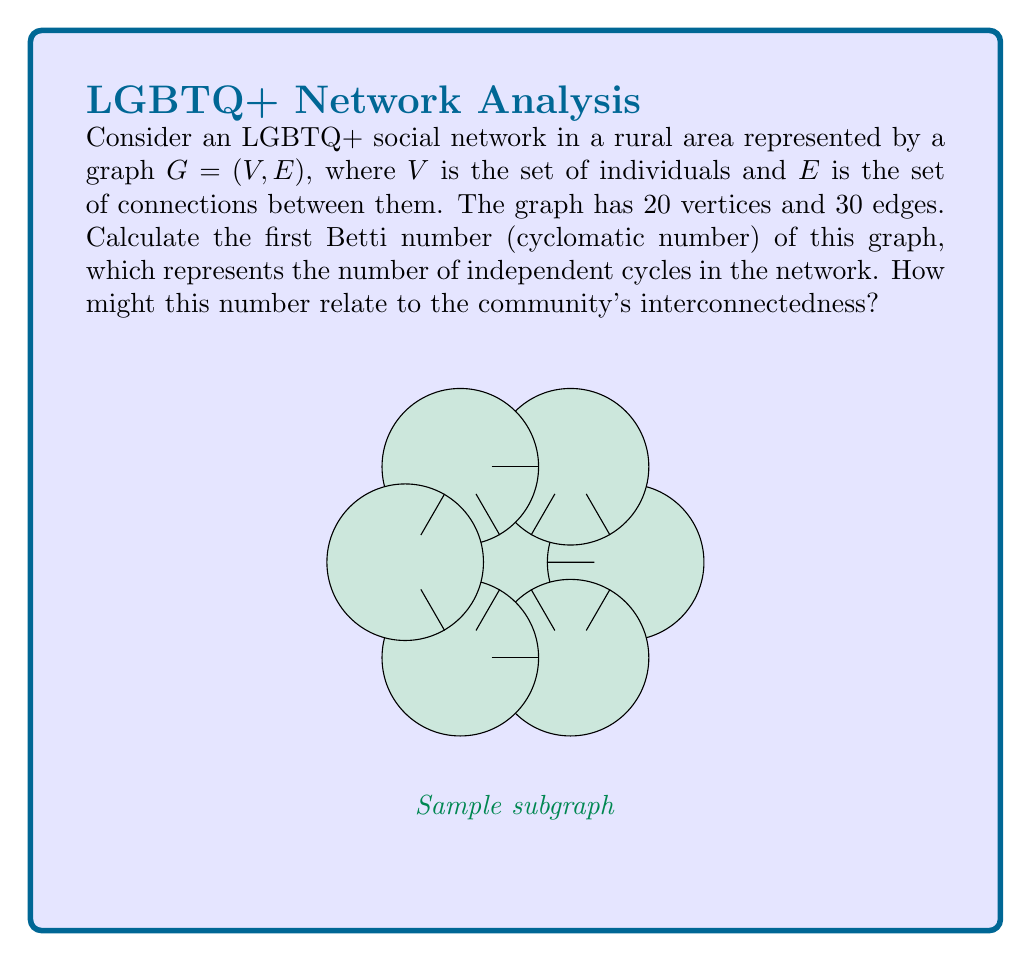Can you solve this math problem? To solve this problem, we'll follow these steps:

1) First, recall the formula for the first Betti number (cyclomatic number) of a graph:

   $$ \beta_1 = |E| - |V| + c $$

   where $|E|$ is the number of edges, $|V|$ is the number of vertices, and $c$ is the number of connected components.

2) We're given that:
   - $|V| = 20$ (number of vertices)
   - $|E| = 30$ (number of edges)

3) We need to determine $c$. Since this represents a social network in a rural area, it's reasonable to assume that all individuals are connected in some way, forming a single component. Therefore, $c = 1$.

4) Now we can substitute these values into our formula:

   $$ \beta_1 = 30 - 20 + 1 = 11 $$

5) Interpretation: The first Betti number of 11 indicates that there are 11 independent cycles in this social network.

In the context of LGBTQ+ communities in rural settings, this number relates to interconnectedness in several ways:

a) It suggests a relatively high level of connectivity for a small community, indicating strong bonds and multiple pathways of connection between individuals.

b) These cycles could represent different social circles or subgroups within the LGBTQ+ community, such as support groups, activity clubs, or advocacy networks.

c) A higher number of cycles implies resilience in the network. If one connection is lost, there are likely alternative paths to maintain community cohesion.

d) For activists and community organizers, understanding this topology can help in designing effective outreach strategies and identifying key connectors in the network.
Answer: 11 